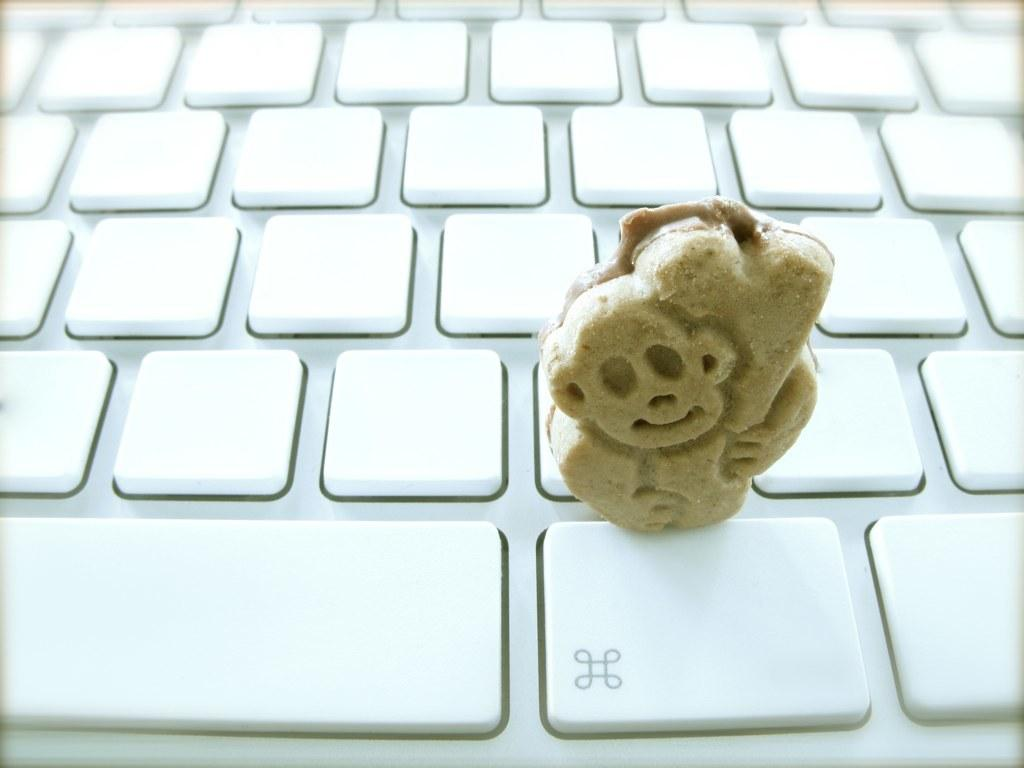What object is present in the image that is not typically used for its intended purpose? There is a toy in the image that is not typically used for its intended purpose. Can you describe the setting in which the toy is placed? The toy is placed on a keyboard. How many bikes are visible in the image? There are no bikes present in the image. What type of force is being applied to the toy in the image? There is no indication of any force being applied to the toy in the image. What role does the sponge play in the image? There is no sponge present in the image. 